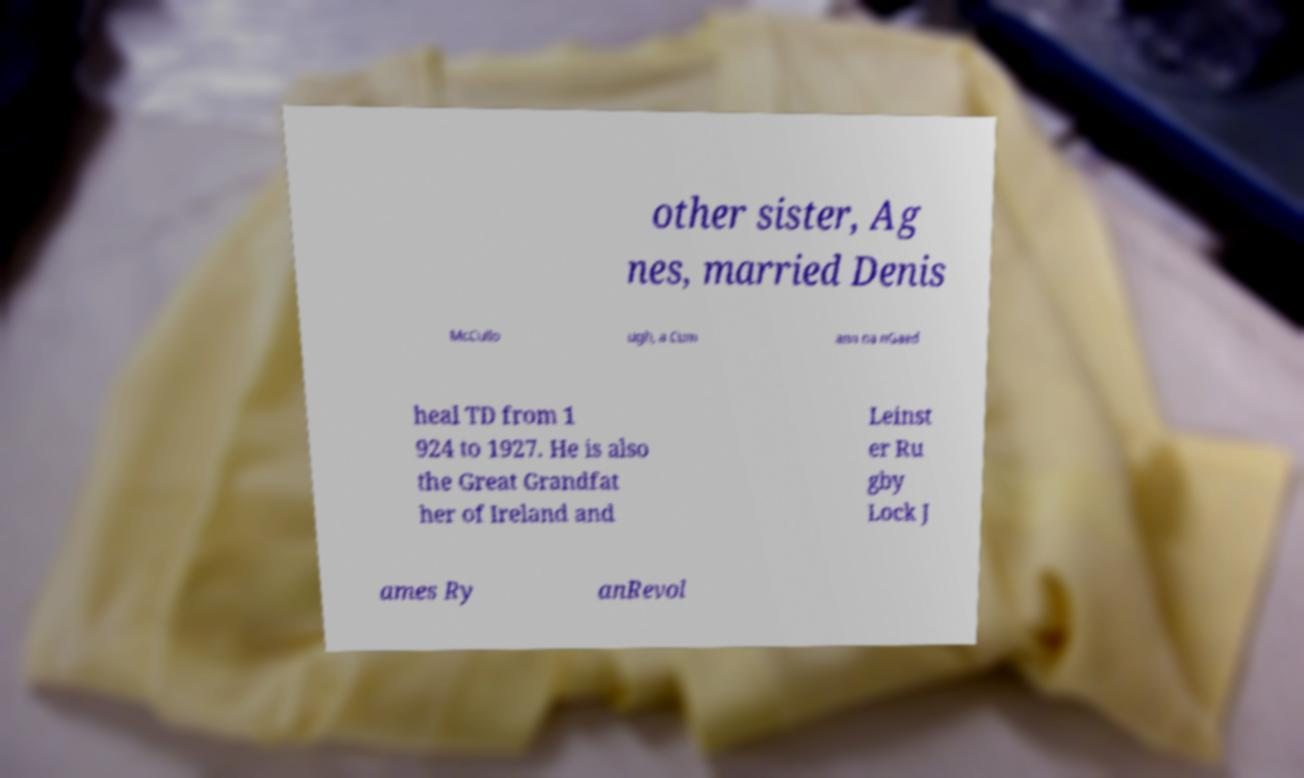What messages or text are displayed in this image? I need them in a readable, typed format. other sister, Ag nes, married Denis McCullo ugh, a Cum ann na nGaed heal TD from 1 924 to 1927. He is also the Great Grandfat her of Ireland and Leinst er Ru gby Lock J ames Ry anRevol 